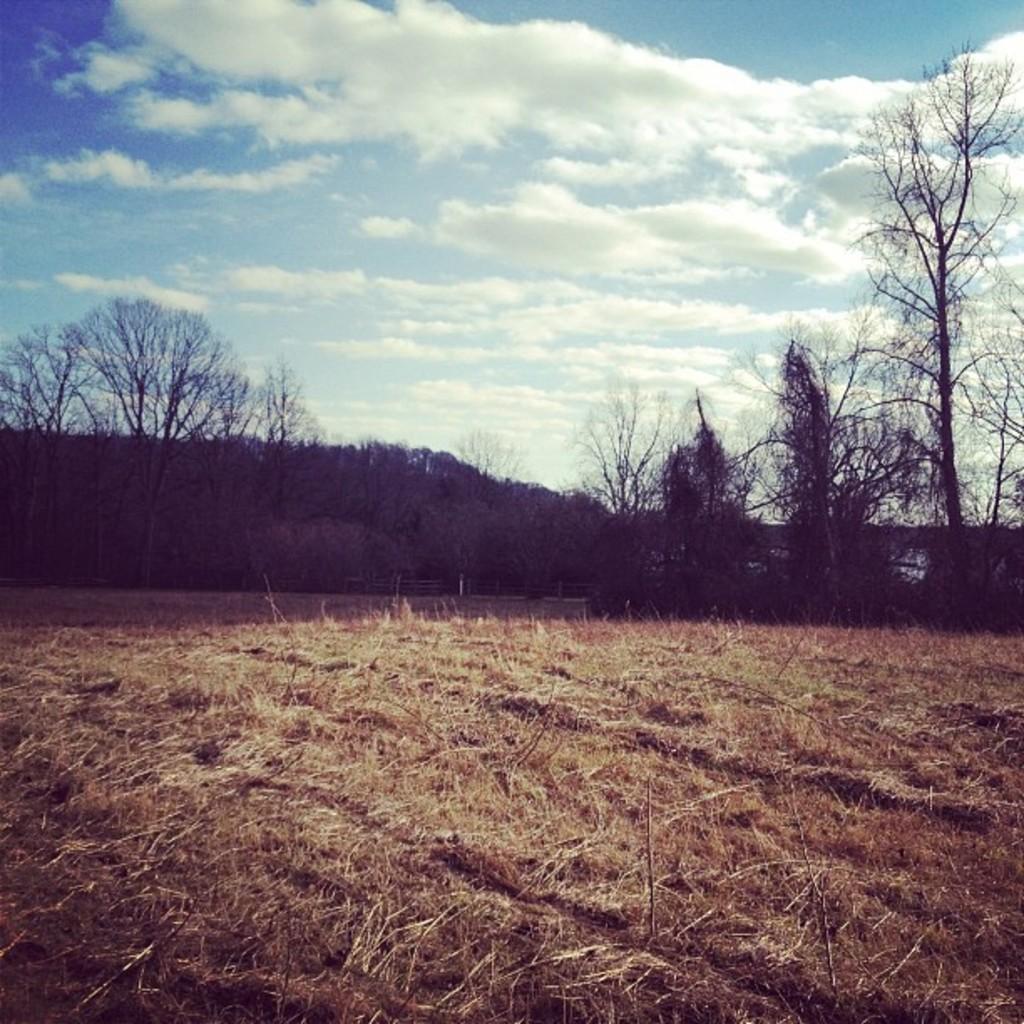Describe this image in one or two sentences. In this image there is a land in the middle. On the land there is dry grass. In the background there are trees. At the top there is sky with the clouds. 